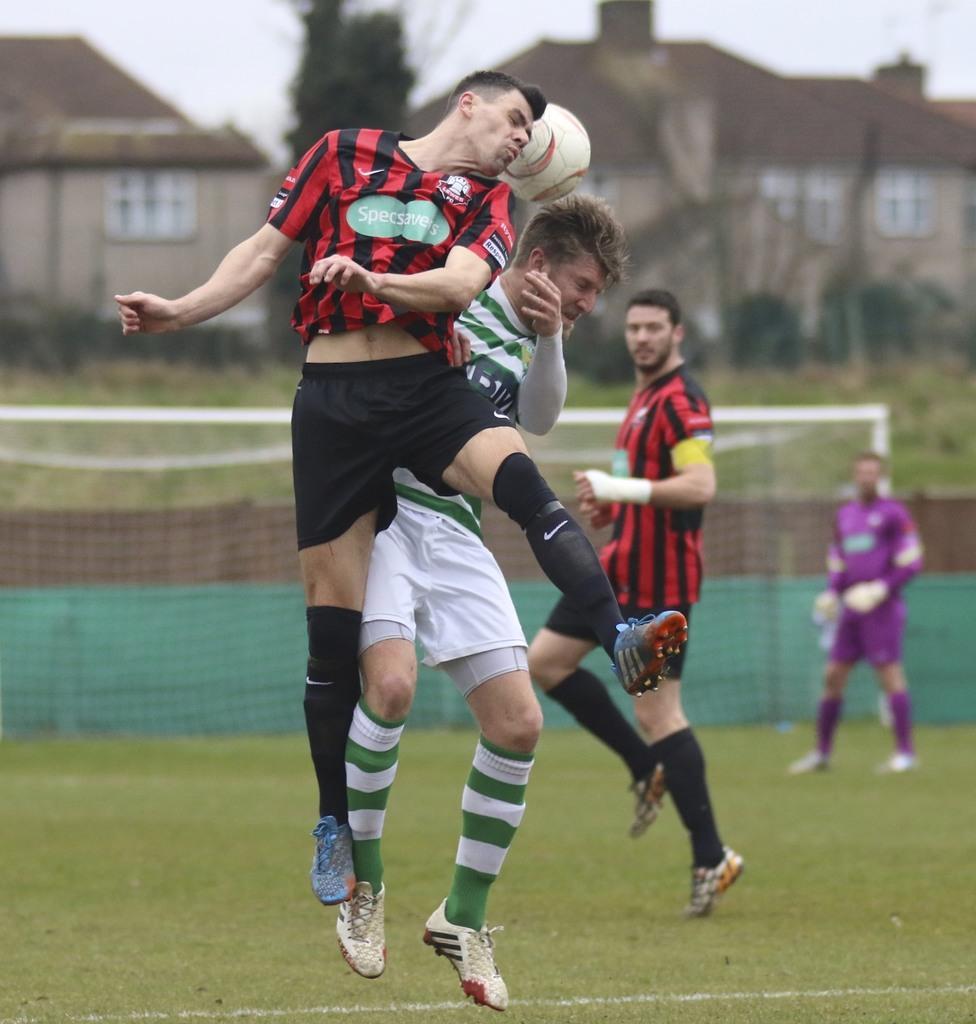How would you summarize this image in a sentence or two? In this picture we can see four persons in the ground. They are playing with the ball. This is mesh. On the background there are houses and this is tree. And there is a sky. 